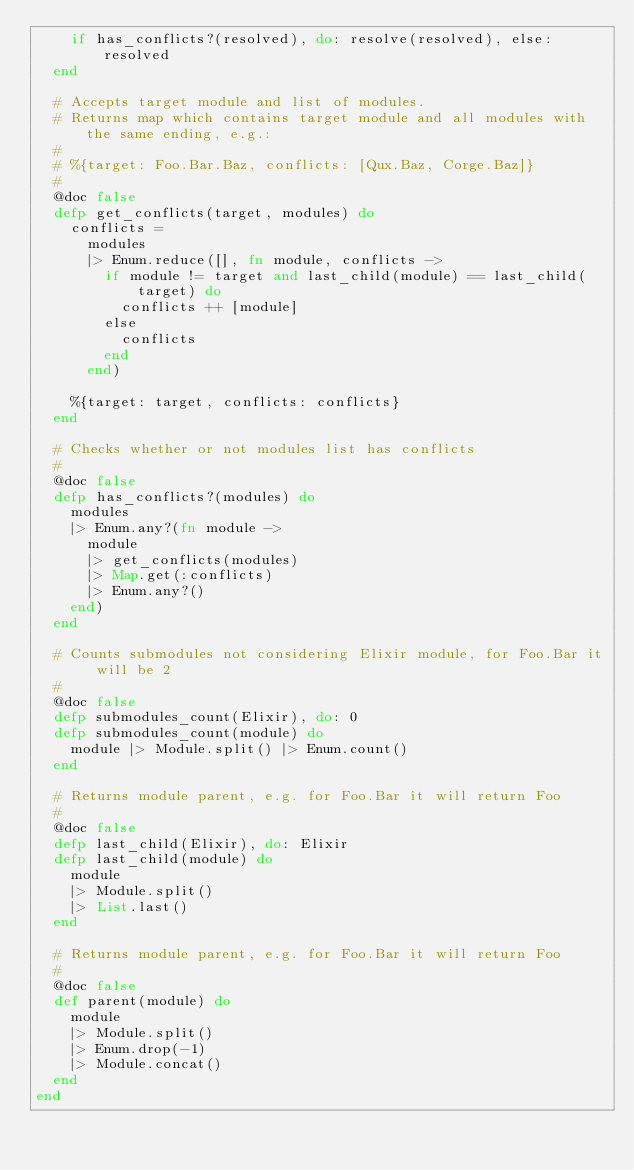<code> <loc_0><loc_0><loc_500><loc_500><_Elixir_>    if has_conflicts?(resolved), do: resolve(resolved), else: resolved
  end

  # Accepts target module and list of modules.
  # Returns map which contains target module and all modules with the same ending, e.g.:
  #
  # %{target: Foo.Bar.Baz, conflicts: [Qux.Baz, Corge.Baz]}
  #
  @doc false
  defp get_conflicts(target, modules) do
    conflicts =
      modules
      |> Enum.reduce([], fn module, conflicts ->
        if module != target and last_child(module) == last_child(target) do
          conflicts ++ [module]
        else
          conflicts
        end
      end)

    %{target: target, conflicts: conflicts}
  end

  # Checks whether or not modules list has conflicts
  #
  @doc false
  defp has_conflicts?(modules) do
    modules
    |> Enum.any?(fn module ->
      module
      |> get_conflicts(modules)
      |> Map.get(:conflicts)
      |> Enum.any?()
    end)
  end

  # Counts submodules not considering Elixir module, for Foo.Bar it will be 2
  #
  @doc false
  defp submodules_count(Elixir), do: 0
  defp submodules_count(module) do
    module |> Module.split() |> Enum.count()
  end

  # Returns module parent, e.g. for Foo.Bar it will return Foo
  #
  @doc false
  defp last_child(Elixir), do: Elixir
  defp last_child(module) do
    module
    |> Module.split()
    |> List.last()
  end

  # Returns module parent, e.g. for Foo.Bar it will return Foo
  #
  @doc false
  def parent(module) do
    module
    |> Module.split()
    |> Enum.drop(-1)
    |> Module.concat()
  end
end
</code> 